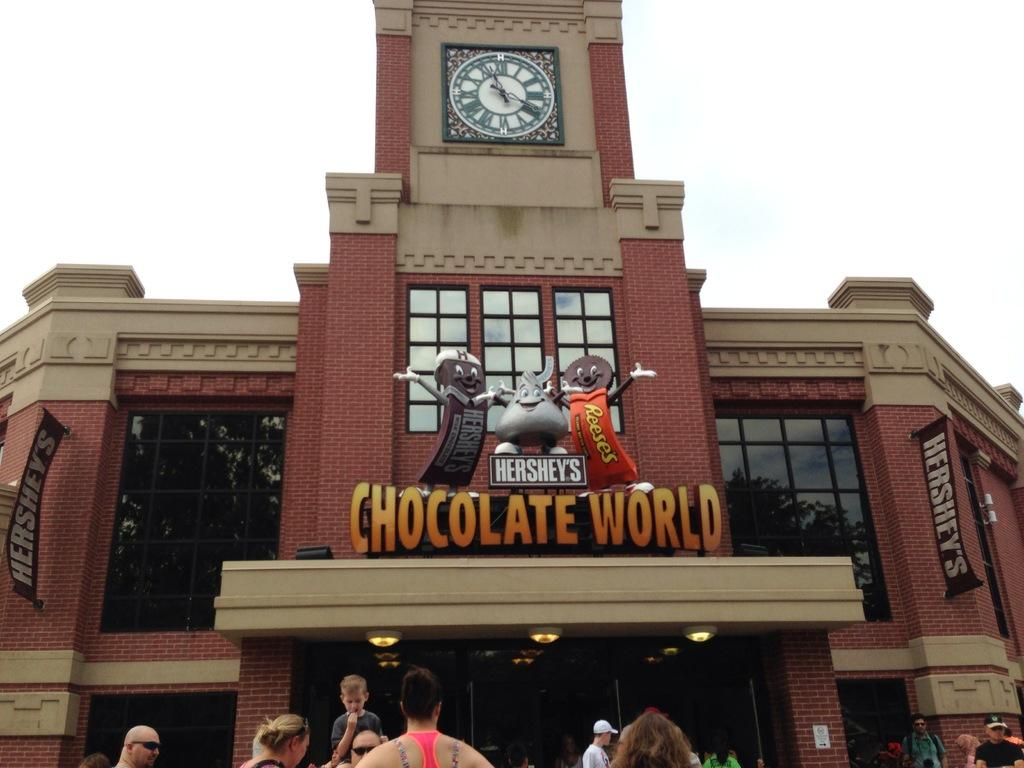What is the main structure in the image? There is a building in the image. What decorations are on the building? There are chocolate toys on the building. What is located at the top of the building? There is a clock at the top of the building. How does the cork affect the rainstorm in the image? There is no cork or rainstorm present in the image. 